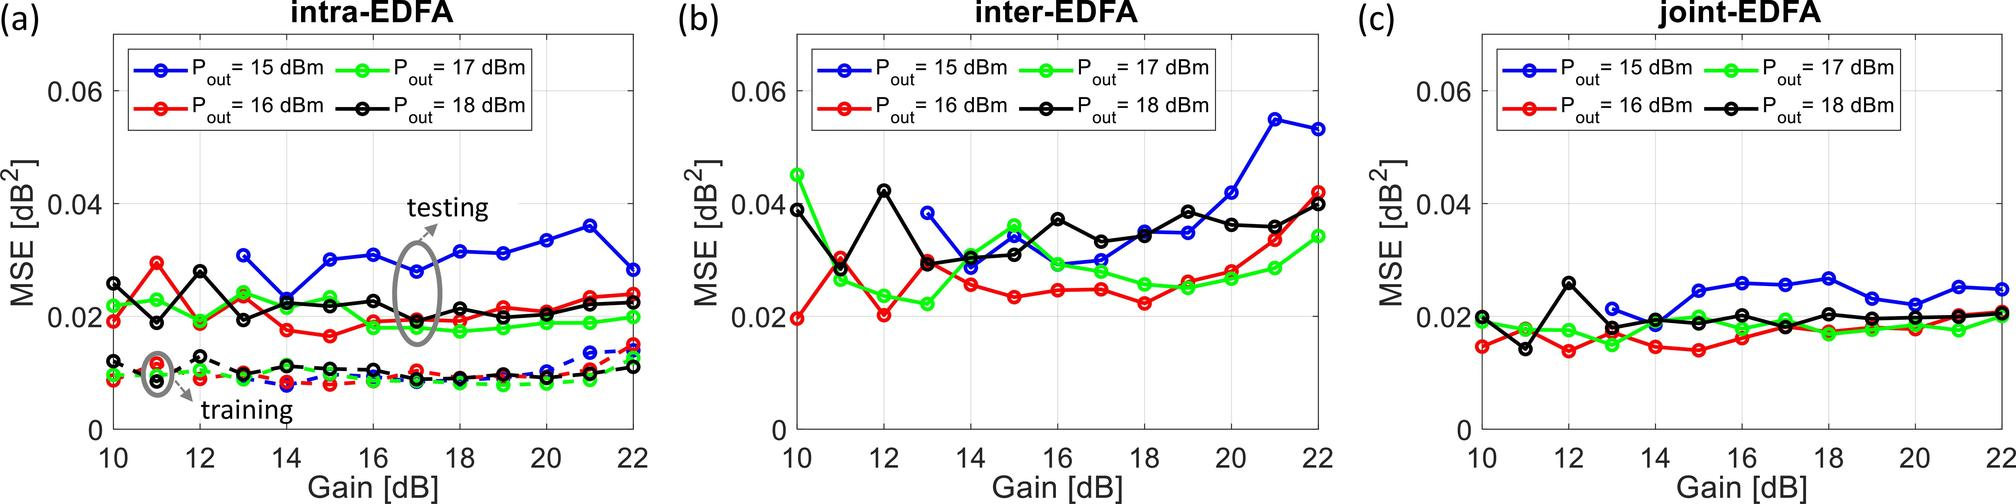What is a common trend observed in the Mean Squared Error (MSE) as the gain increases in the intra-EDFA configuration for different output powers in Figure (a)? Upon examining Figure (a), we can discern that the Mean Squared Error (MSE) exhibits a distinct pattern dependent on the gain within the intra-EDFA configuration. As the gain starts to increase from 10 dB, there is a noticeable reduction in MSE across the varying output power levels, signified by the downward trend of the curves. This trend continues until we reach a gain of about 16 dB, following which the MSE tends to enter a plateau phase with minor fluctuations. This behavior is consistent across all depicted output power levels, indicating that the system reaches an optimal operating point beyond which additional gain increments contribute marginally to reducing MSE. Hence, the answer to the observed trend is that MSE decreases with the gain initially, and then plateaus or experiences trivial undulations as the gain further increases. 